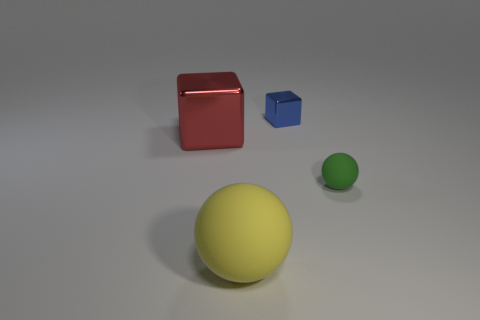What size is the red thing that is the same material as the blue object?
Provide a succinct answer. Large. There is a tiny sphere that is the same material as the large yellow thing; what is its color?
Your answer should be very brief. Green. Is there a green object of the same size as the red block?
Your answer should be compact. No. There is a green thing that is the same shape as the large yellow rubber object; what is its material?
Your response must be concise. Rubber. There is a yellow matte thing that is the same size as the red thing; what shape is it?
Make the answer very short. Sphere. Is there a small object of the same shape as the large yellow thing?
Your response must be concise. Yes. There is a small object that is in front of the block on the left side of the blue shiny cube; what is its shape?
Ensure brevity in your answer.  Sphere. What is the shape of the small matte thing?
Provide a short and direct response. Sphere. What is the material of the red object that is left of the small green matte sphere to the right of the metal thing that is behind the big red shiny block?
Offer a terse response. Metal. What number of other things are there of the same material as the small blue cube
Your answer should be compact. 1. 